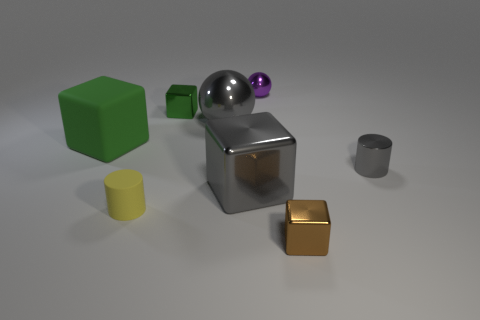Is the number of tiny green metallic cubes in front of the purple ball greater than the number of brown metallic blocks?
Provide a short and direct response. No. What number of objects are either big purple metal cylinders or big metal objects in front of the small gray cylinder?
Provide a short and direct response. 1. Are there more big objects behind the large gray ball than gray things behind the small green object?
Offer a very short reply. No. There is a tiny cube that is behind the tiny cylinder that is behind the tiny cylinder left of the purple shiny thing; what is its material?
Provide a short and direct response. Metal. The brown object that is made of the same material as the gray cube is what shape?
Offer a terse response. Cube. Are there any large green rubber cubes right of the tiny block that is in front of the small yellow thing?
Provide a succinct answer. No. The green metallic thing has what size?
Offer a very short reply. Small. How many things are either small brown blocks or tiny yellow cylinders?
Your answer should be compact. 2. Is the material of the large thing in front of the tiny gray cylinder the same as the green block that is in front of the large ball?
Keep it short and to the point. No. What color is the cylinder that is made of the same material as the small brown object?
Ensure brevity in your answer.  Gray. 